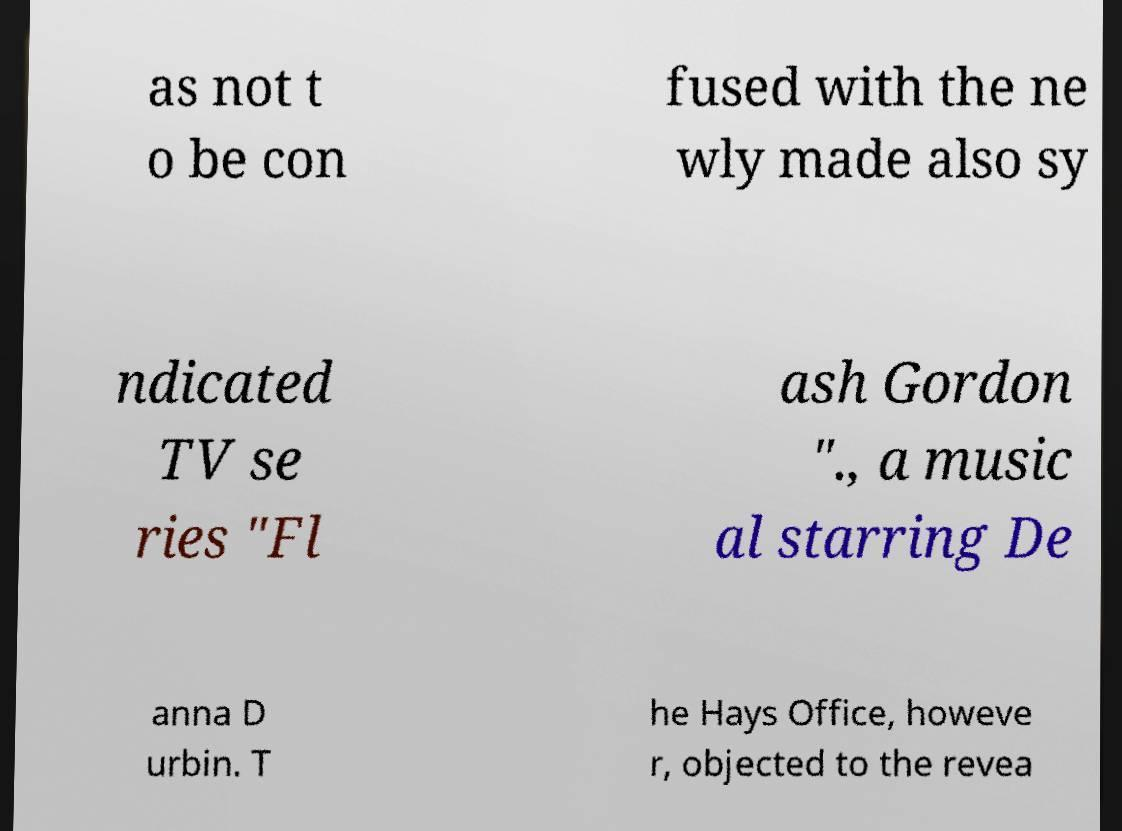Could you extract and type out the text from this image? as not t o be con fused with the ne wly made also sy ndicated TV se ries "Fl ash Gordon "., a music al starring De anna D urbin. T he Hays Office, howeve r, objected to the revea 